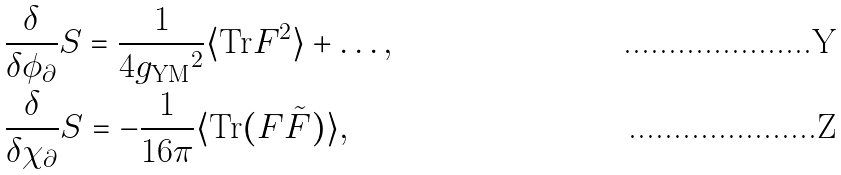<formula> <loc_0><loc_0><loc_500><loc_500>& \frac { \delta } { \delta \phi _ { \partial } } S = \frac { 1 } { 4 { g _ { \text {YM} } } ^ { 2 } } \langle \text {Tr} F ^ { 2 } \rangle + \dots , \\ & \frac { \delta } { \delta \chi _ { \partial } } S = - \frac { 1 } { 1 6 \pi } \langle \text {Tr} ( F \tilde { F } ) \rangle ,</formula> 